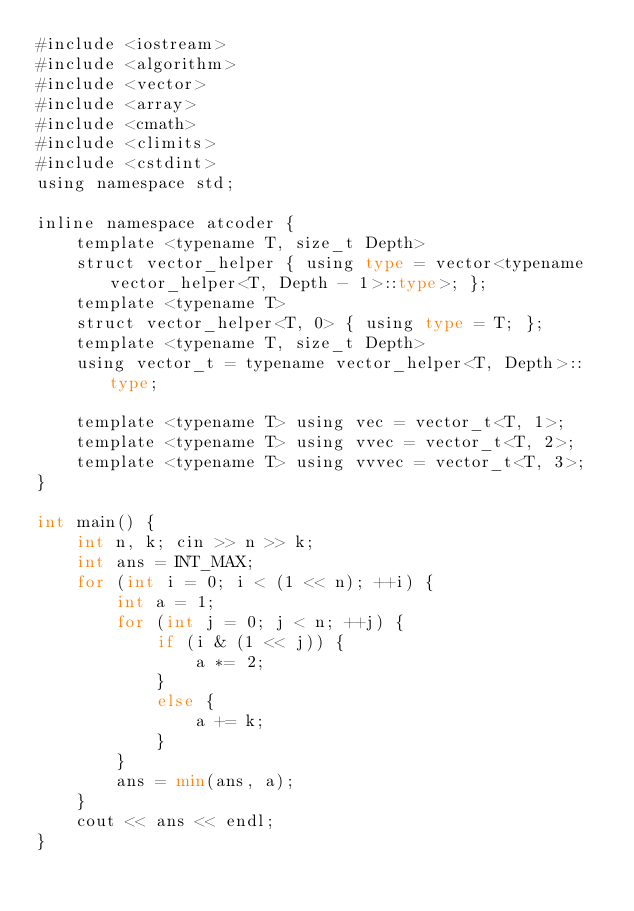Convert code to text. <code><loc_0><loc_0><loc_500><loc_500><_Python_>#include <iostream>
#include <algorithm>
#include <vector>
#include <array>
#include <cmath>
#include <climits>
#include <cstdint>
using namespace std;

inline namespace atcoder {
    template <typename T, size_t Depth>
    struct vector_helper { using type = vector<typename vector_helper<T, Depth - 1>::type>; };
    template <typename T>
    struct vector_helper<T, 0> { using type = T; };
    template <typename T, size_t Depth>
    using vector_t = typename vector_helper<T, Depth>::type;

    template <typename T> using vec = vector_t<T, 1>;
    template <typename T> using vvec = vector_t<T, 2>;
    template <typename T> using vvvec = vector_t<T, 3>;
}

int main() {
    int n, k; cin >> n >> k;
    int ans = INT_MAX;
    for (int i = 0; i < (1 << n); ++i) {
        int a = 1;
        for (int j = 0; j < n; ++j) {
            if (i & (1 << j)) {
                a *= 2;
            }
            else {
                a += k;
            }
        }
        ans = min(ans, a);
    }
    cout << ans << endl;
}

</code> 